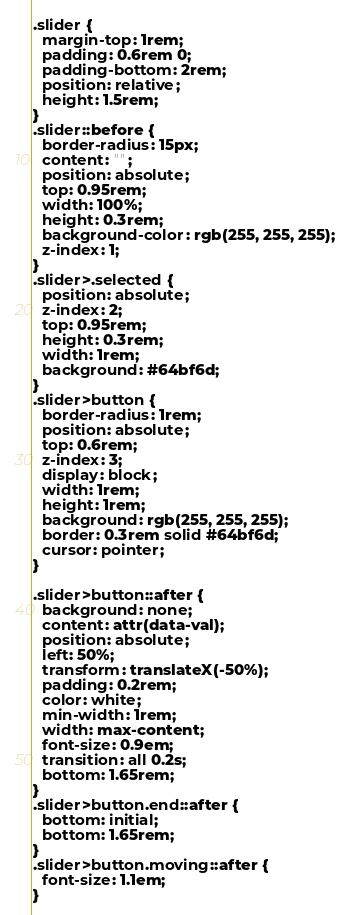<code> <loc_0><loc_0><loc_500><loc_500><_CSS_>.slider {
  margin-top: 1rem;
  padding: 0.6rem 0;
  padding-bottom: 2rem;
  position: relative;
  height: 1.5rem;
}
.slider::before {
  border-radius: 15px;
  content: "";
  position: absolute;
  top: 0.95rem;
  width: 100%;
  height: 0.3rem;
  background-color: rgb(255, 255, 255);
  z-index: 1;
}
.slider>.selected {
  position: absolute;
  z-index: 2;
  top: 0.95rem;
  height: 0.3rem;
  width: 1rem;
  background: #64bf6d;
}
.slider>button {
  border-radius: 1rem;
  position: absolute;
  top: 0.6rem;
  z-index: 3;
  display: block;
  width: 1rem;
  height: 1rem;
  background: rgb(255, 255, 255);
  border: 0.3rem solid #64bf6d;
  cursor: pointer;
}

.slider>button::after {
  background: none;
  content: attr(data-val);
  position: absolute;
  left: 50%;
  transform: translateX(-50%);
  padding: 0.2rem;
  color: white;
  min-width: 1rem;
  width: max-content;
  font-size: 0.9em;
  transition: all 0.2s;
  bottom: 1.65rem;
}
.slider>button.end::after {
  bottom: initial;
  bottom: 1.65rem;
}
.slider>button.moving::after {
  font-size: 1.1em;
}</code> 